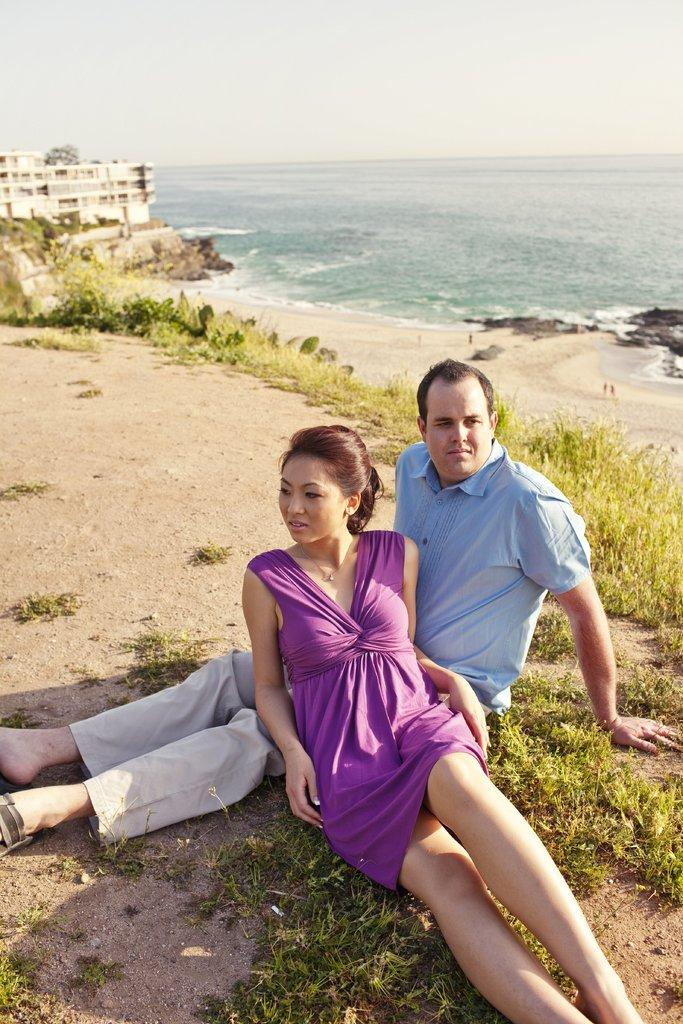What types of people are in the image? There are women and men in the image. Where are the people located in the image? They are on the ground. What type of vegetation is present in the image? There are plants and grass in the image. What natural feature can be seen at the top of the image? The ocean is visible at the top of the image. What type of structure is present in the image? There is a building in the image. What part of the sky is visible in the image? The sky is visible at the top of the image. How many oranges are being held by the people in the image? There are no oranges present in the image. How long does it take for the minute hand to move in the image? There is no clock or time-related element in the image, so it's not possible to determine the movement of a minute hand. 